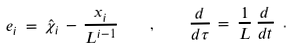Convert formula to latex. <formula><loc_0><loc_0><loc_500><loc_500>e _ { i } \, = \, \hat { \chi } _ { i } \, - \, \frac { x _ { i } } { L ^ { i - 1 } } \quad , \quad \frac { d } { d \tau } \, = \, \frac { 1 } { L } \, \frac { d } { d t } \ .</formula> 